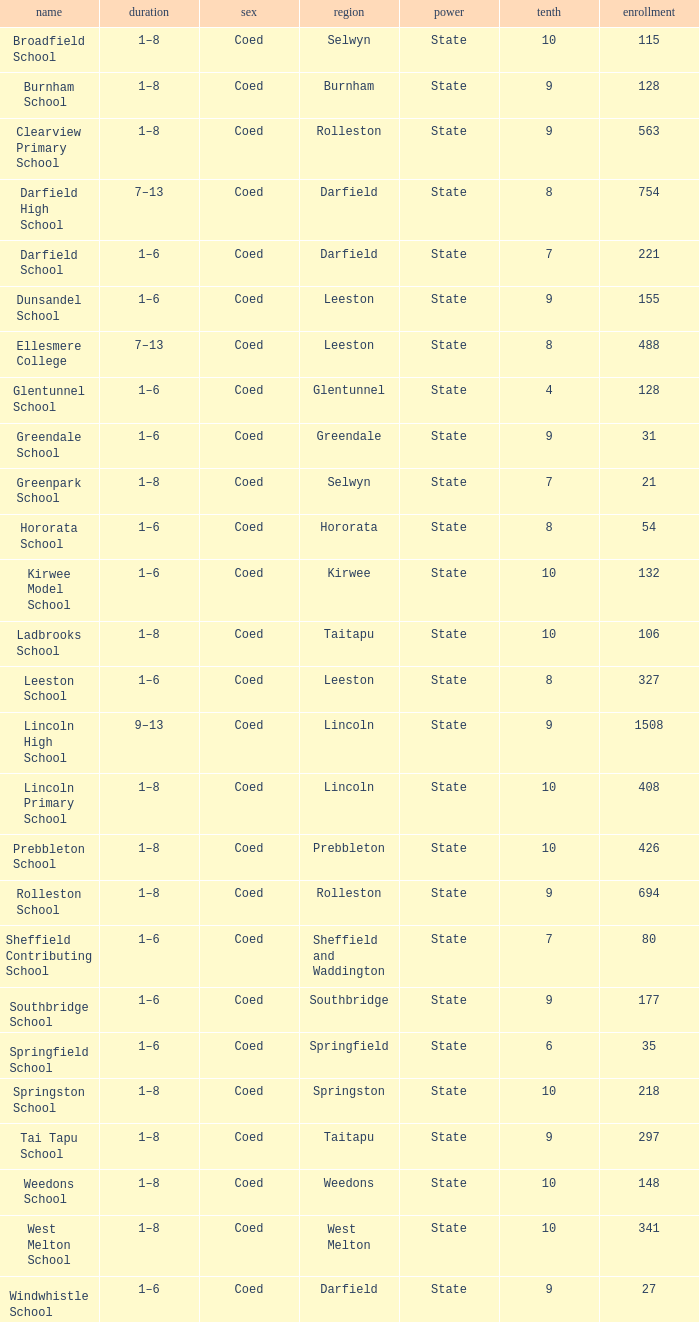Which area has a Decile of 9, and a Roll of 31? Greendale. Can you parse all the data within this table? {'header': ['name', 'duration', 'sex', 'region', 'power', 'tenth', 'enrollment'], 'rows': [['Broadfield School', '1–8', 'Coed', 'Selwyn', 'State', '10', '115'], ['Burnham School', '1–8', 'Coed', 'Burnham', 'State', '9', '128'], ['Clearview Primary School', '1–8', 'Coed', 'Rolleston', 'State', '9', '563'], ['Darfield High School', '7–13', 'Coed', 'Darfield', 'State', '8', '754'], ['Darfield School', '1–6', 'Coed', 'Darfield', 'State', '7', '221'], ['Dunsandel School', '1–6', 'Coed', 'Leeston', 'State', '9', '155'], ['Ellesmere College', '7–13', 'Coed', 'Leeston', 'State', '8', '488'], ['Glentunnel School', '1–6', 'Coed', 'Glentunnel', 'State', '4', '128'], ['Greendale School', '1–6', 'Coed', 'Greendale', 'State', '9', '31'], ['Greenpark School', '1–8', 'Coed', 'Selwyn', 'State', '7', '21'], ['Hororata School', '1–6', 'Coed', 'Hororata', 'State', '8', '54'], ['Kirwee Model School', '1–6', 'Coed', 'Kirwee', 'State', '10', '132'], ['Ladbrooks School', '1–8', 'Coed', 'Taitapu', 'State', '10', '106'], ['Leeston School', '1–6', 'Coed', 'Leeston', 'State', '8', '327'], ['Lincoln High School', '9–13', 'Coed', 'Lincoln', 'State', '9', '1508'], ['Lincoln Primary School', '1–8', 'Coed', 'Lincoln', 'State', '10', '408'], ['Prebbleton School', '1–8', 'Coed', 'Prebbleton', 'State', '10', '426'], ['Rolleston School', '1–8', 'Coed', 'Rolleston', 'State', '9', '694'], ['Sheffield Contributing School', '1–6', 'Coed', 'Sheffield and Waddington', 'State', '7', '80'], ['Southbridge School', '1–6', 'Coed', 'Southbridge', 'State', '9', '177'], ['Springfield School', '1–6', 'Coed', 'Springfield', 'State', '6', '35'], ['Springston School', '1–8', 'Coed', 'Springston', 'State', '10', '218'], ['Tai Tapu School', '1–8', 'Coed', 'Taitapu', 'State', '9', '297'], ['Weedons School', '1–8', 'Coed', 'Weedons', 'State', '10', '148'], ['West Melton School', '1–8', 'Coed', 'West Melton', 'State', '10', '341'], ['Windwhistle School', '1–6', 'Coed', 'Darfield', 'State', '9', '27']]} 